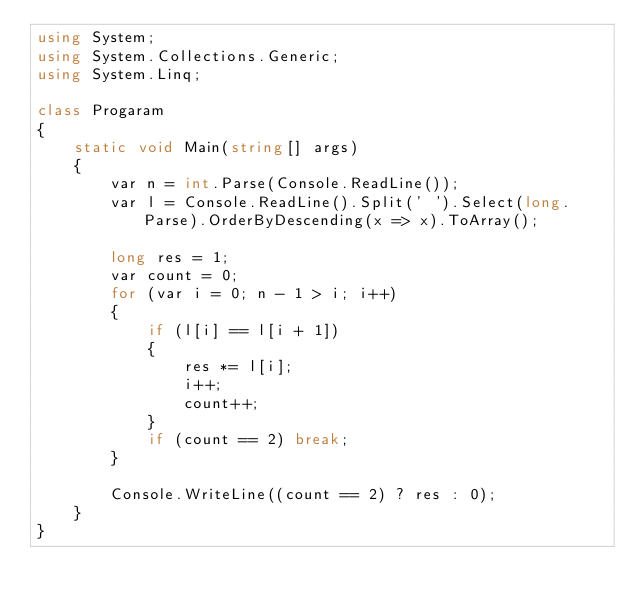Convert code to text. <code><loc_0><loc_0><loc_500><loc_500><_C#_>using System;
using System.Collections.Generic;
using System.Linq;

class Progaram
{
    static void Main(string[] args)
    {
        var n = int.Parse(Console.ReadLine());
        var l = Console.ReadLine().Split(' ').Select(long.Parse).OrderByDescending(x => x).ToArray();

        long res = 1;
        var count = 0;
        for (var i = 0; n - 1 > i; i++)
        {
            if (l[i] == l[i + 1])
            {
                res *= l[i];
                i++;
                count++;
            }
            if (count == 2) break;
        }

        Console.WriteLine((count == 2) ? res : 0);
    }
}</code> 